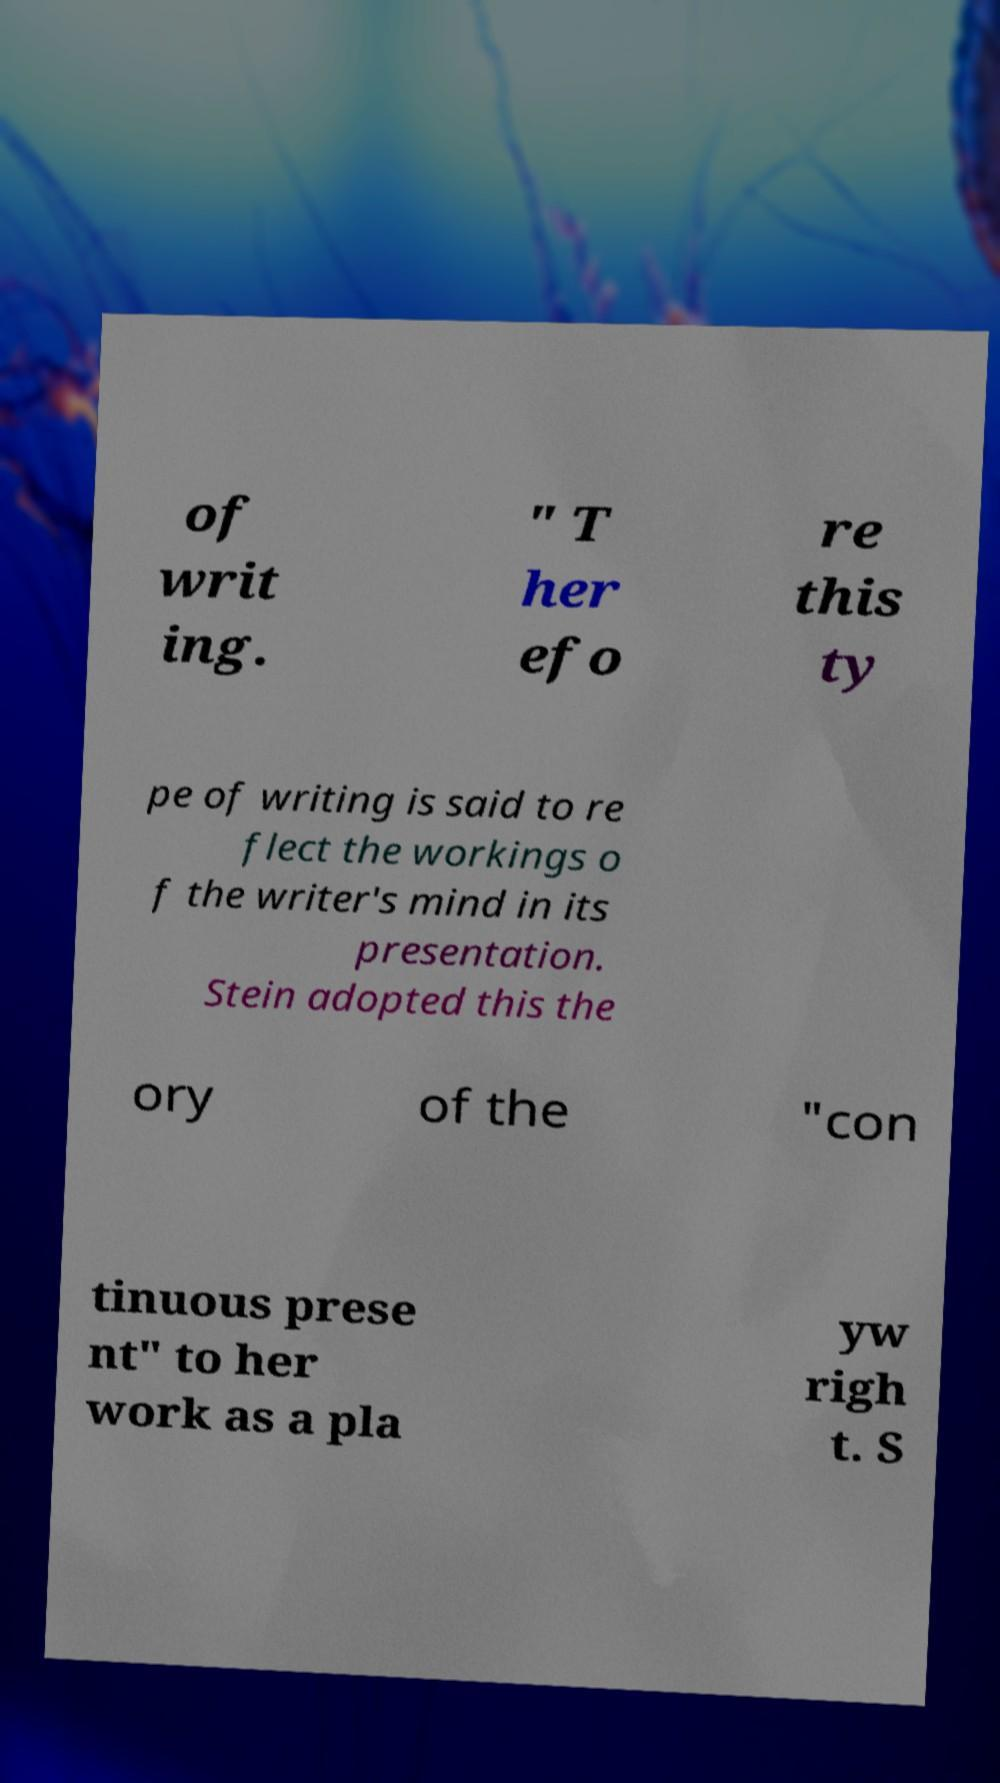Please identify and transcribe the text found in this image. of writ ing. " T her efo re this ty pe of writing is said to re flect the workings o f the writer's mind in its presentation. Stein adopted this the ory of the "con tinuous prese nt" to her work as a pla yw righ t. S 